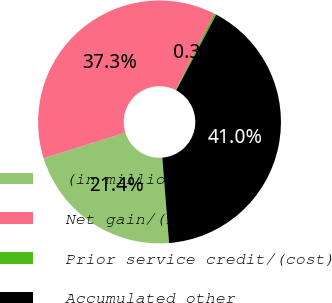Convert chart. <chart><loc_0><loc_0><loc_500><loc_500><pie_chart><fcel>(in millions)<fcel>Net gain/(loss)<fcel>Prior service credit/(cost)<fcel>Accumulated other<nl><fcel>21.43%<fcel>37.28%<fcel>0.28%<fcel>41.01%<nl></chart> 